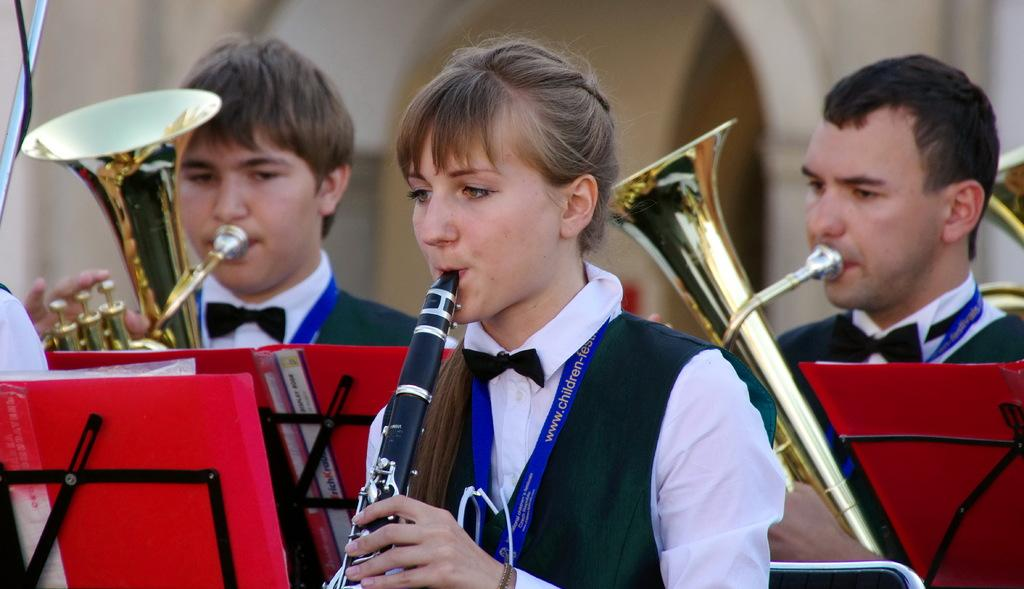Who is present in the image? There is a woman and two men in the image. What are the woman and men doing in the image? The woman and men are playing musical instruments. What can be seen in front of the people in the image? There are metal stands in front of the people. What is visible in the background of the image? There is a wall in the background of the image. What type of bushes can be seen growing on the elbow of the woman in the image? There are no bushes visible in the image, and the woman's elbow is not mentioned in the provided facts. 